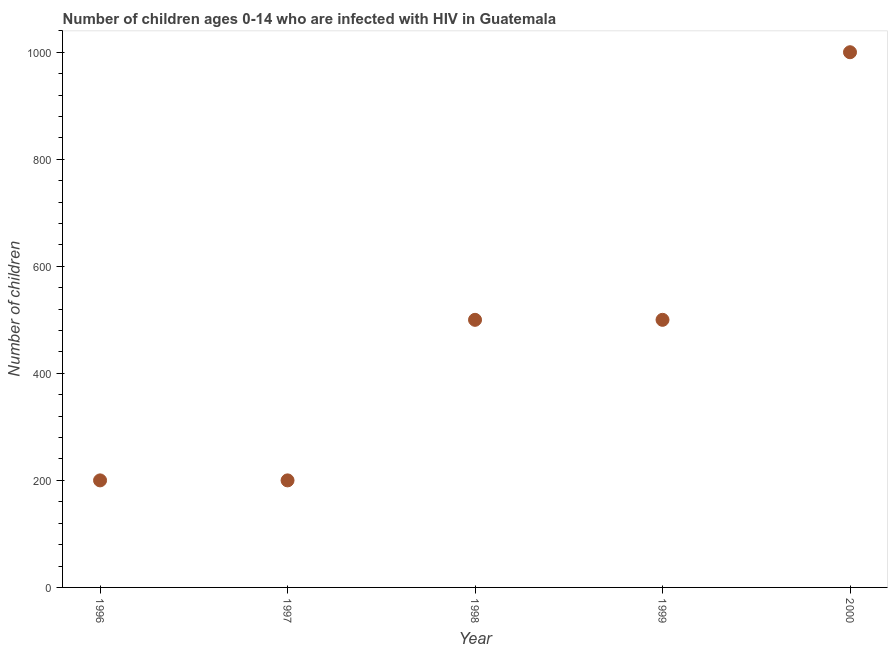What is the number of children living with hiv in 1997?
Ensure brevity in your answer.  200. Across all years, what is the maximum number of children living with hiv?
Offer a terse response. 1000. Across all years, what is the minimum number of children living with hiv?
Your answer should be compact. 200. What is the sum of the number of children living with hiv?
Provide a short and direct response. 2400. What is the difference between the number of children living with hiv in 1996 and 2000?
Give a very brief answer. -800. What is the average number of children living with hiv per year?
Make the answer very short. 480. What is the median number of children living with hiv?
Offer a very short reply. 500. Is the number of children living with hiv in 1997 less than that in 1998?
Provide a succinct answer. Yes. What is the difference between the highest and the lowest number of children living with hiv?
Give a very brief answer. 800. In how many years, is the number of children living with hiv greater than the average number of children living with hiv taken over all years?
Provide a short and direct response. 3. How many dotlines are there?
Your response must be concise. 1. What is the difference between two consecutive major ticks on the Y-axis?
Offer a terse response. 200. What is the title of the graph?
Provide a succinct answer. Number of children ages 0-14 who are infected with HIV in Guatemala. What is the label or title of the X-axis?
Your response must be concise. Year. What is the label or title of the Y-axis?
Offer a terse response. Number of children. What is the Number of children in 1996?
Your answer should be very brief. 200. What is the Number of children in 1999?
Keep it short and to the point. 500. What is the Number of children in 2000?
Provide a short and direct response. 1000. What is the difference between the Number of children in 1996 and 1998?
Offer a very short reply. -300. What is the difference between the Number of children in 1996 and 1999?
Your answer should be compact. -300. What is the difference between the Number of children in 1996 and 2000?
Offer a very short reply. -800. What is the difference between the Number of children in 1997 and 1998?
Provide a short and direct response. -300. What is the difference between the Number of children in 1997 and 1999?
Ensure brevity in your answer.  -300. What is the difference between the Number of children in 1997 and 2000?
Offer a very short reply. -800. What is the difference between the Number of children in 1998 and 1999?
Ensure brevity in your answer.  0. What is the difference between the Number of children in 1998 and 2000?
Provide a short and direct response. -500. What is the difference between the Number of children in 1999 and 2000?
Keep it short and to the point. -500. What is the ratio of the Number of children in 1996 to that in 1997?
Give a very brief answer. 1. What is the ratio of the Number of children in 1996 to that in 1998?
Give a very brief answer. 0.4. What is the ratio of the Number of children in 1996 to that in 2000?
Give a very brief answer. 0.2. What is the ratio of the Number of children in 1997 to that in 1998?
Offer a very short reply. 0.4. What is the ratio of the Number of children in 1997 to that in 1999?
Your answer should be very brief. 0.4. What is the ratio of the Number of children in 1998 to that in 1999?
Provide a short and direct response. 1. 